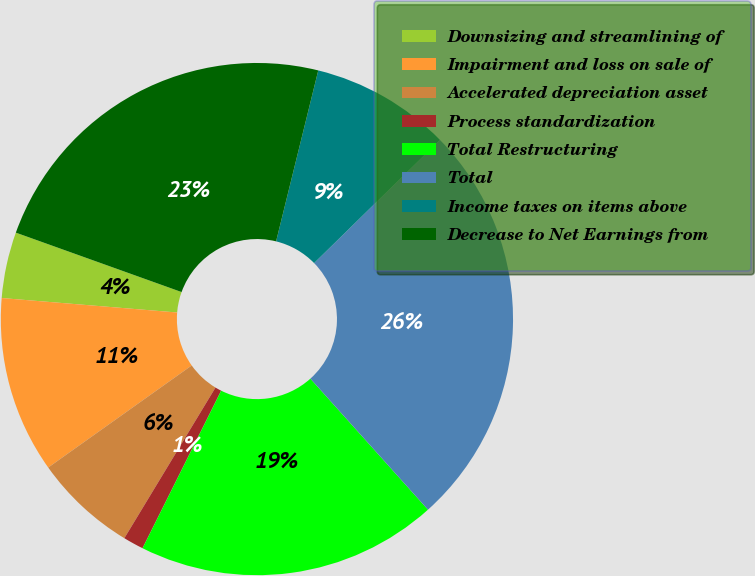Convert chart to OTSL. <chart><loc_0><loc_0><loc_500><loc_500><pie_chart><fcel>Downsizing and streamlining of<fcel>Impairment and loss on sale of<fcel>Accelerated depreciation asset<fcel>Process standardization<fcel>Total Restructuring<fcel>Total<fcel>Income taxes on items above<fcel>Decrease to Net Earnings from<nl><fcel>4.17%<fcel>11.15%<fcel>6.5%<fcel>1.29%<fcel>19.01%<fcel>25.69%<fcel>8.82%<fcel>23.37%<nl></chart> 